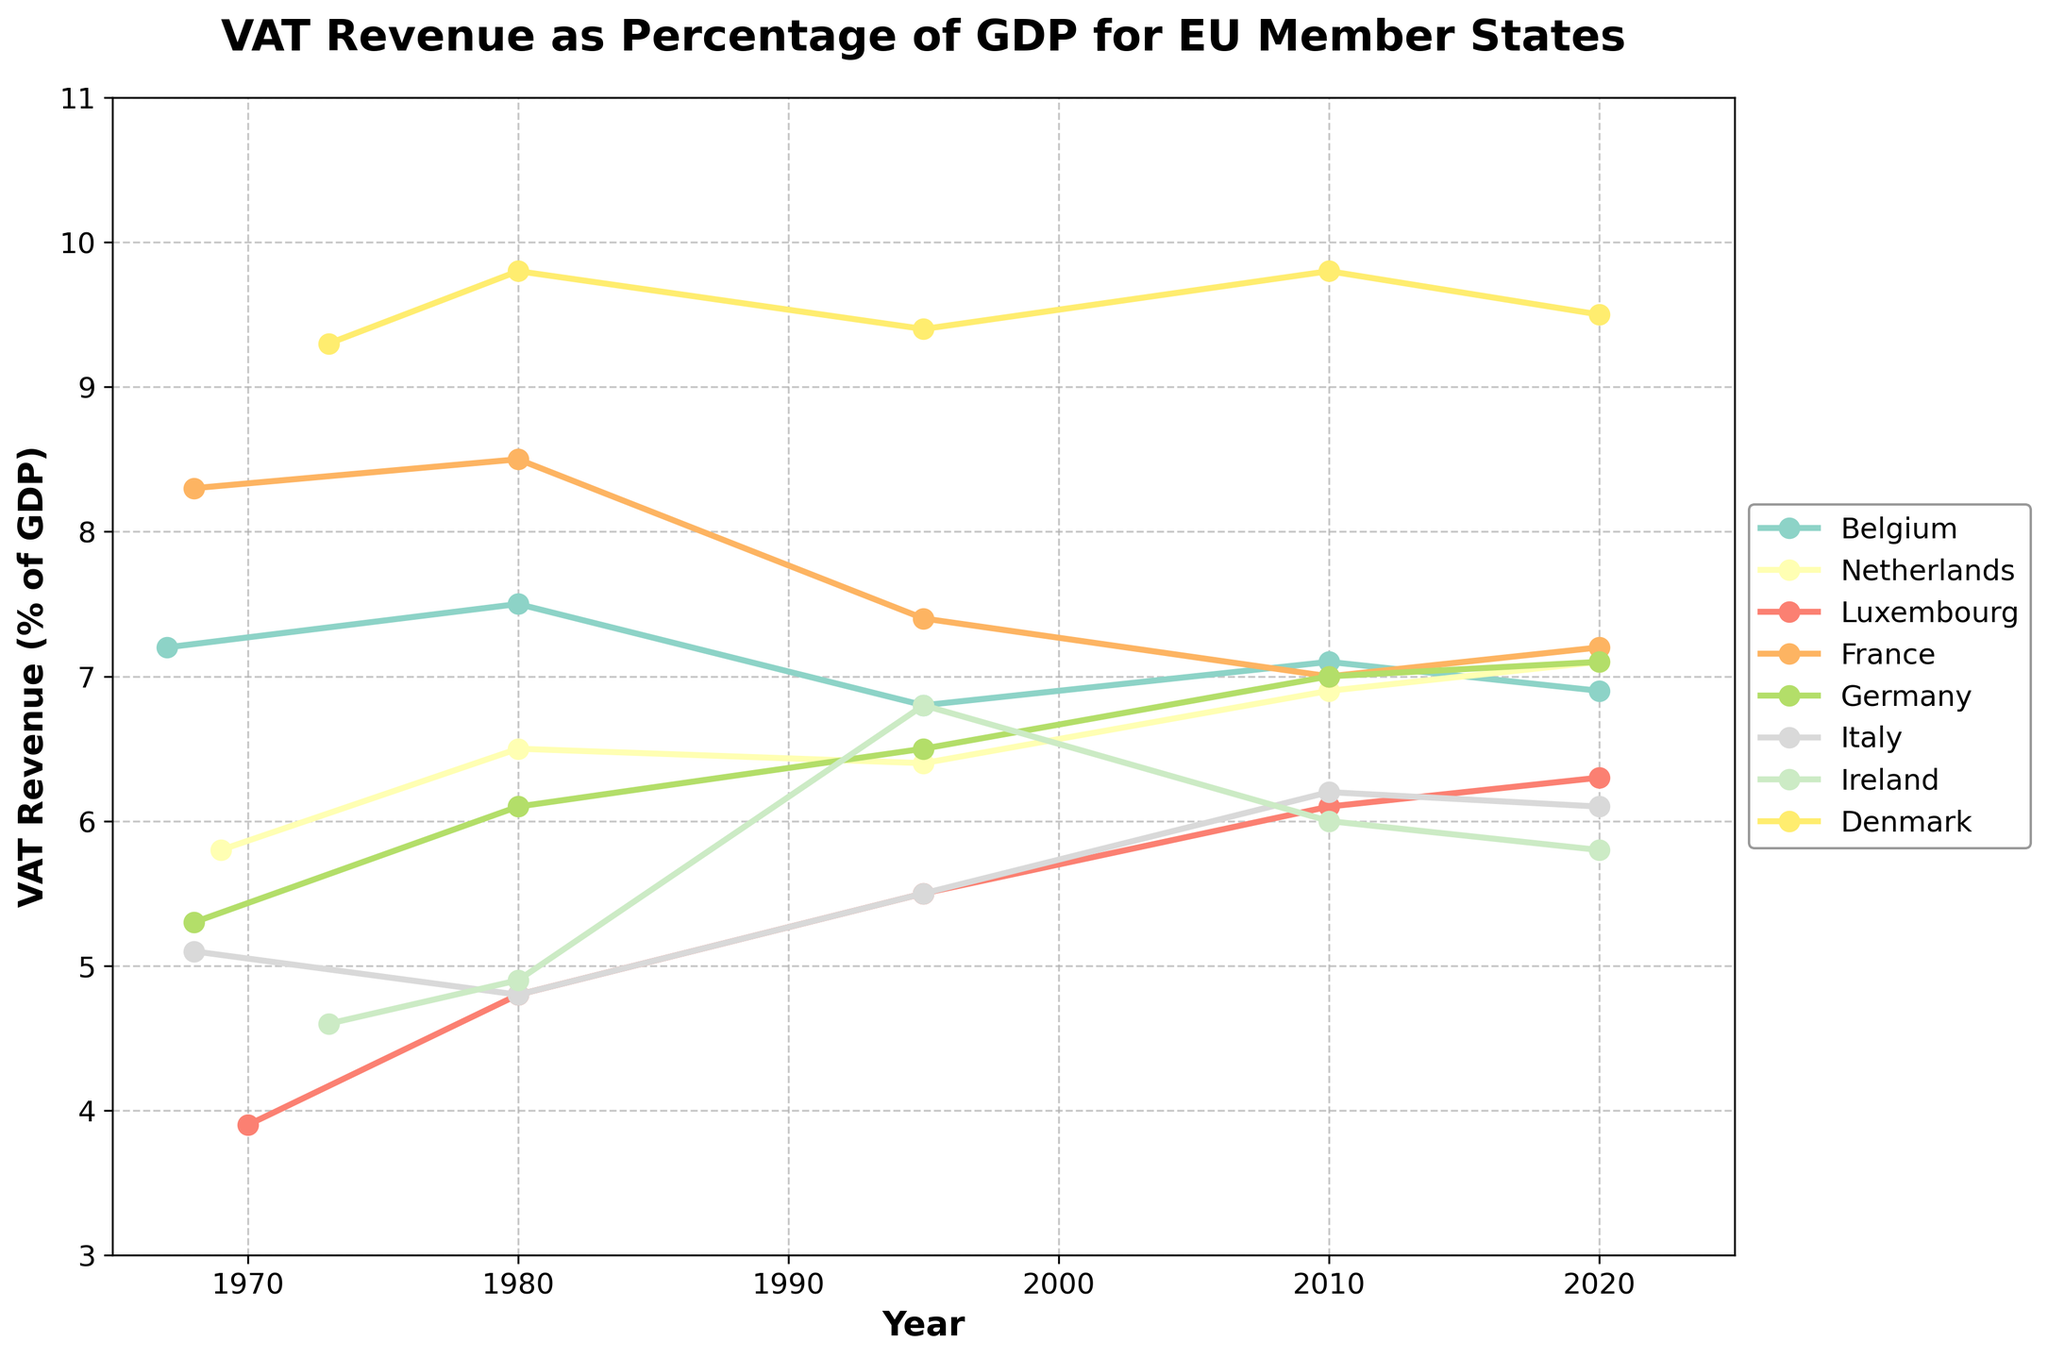What's the trend of VAT revenue as a percentage of GDP for Belgium from 1967 to 2020? The plot shows the VAT revenue for Belgium starts at 7.2% in 1967, increases to 7.5% in 1980, decreases to 6.8% in 1995, rises slightly to 7.1% in 2010, and then decreases to 6.9% by 2020.
Answer: Fluctuating with a slight decrease overall Which country had the highest VAT revenue as a percentage of GDP in 1980? By examining the 1980 line for all countries, Denmark's line is the highest at 9.8%, surpassing other countries.
Answer: Denmark Between Belgium and Netherlands, which country showed a greater increase in VAT revenue as a percentage of GDP from 1995 to 2020? Belgium's VAT revenue increased from 6.8% in 1995 to 6.9% in 2020 (0.1% increase), while Netherlands' increased from 6.4% in 1995 to 7.1% in 2020 (0.7% increase).
Answer: Netherlands Which country showed the most stable VAT revenue as a percentage of GDP over the years? By observing the lines, Denmark's VAT revenue fluctuates the least, maintaining values close to 9.3%-9.8%.
Answer: Denmark Did France's VAT revenue as a percentage of GDP ever drop below 7% after joining the EU? France's line shows its VAT revenue dropped from 8.3% in 1968 to 7.4% in 1995 and further to 7.0% in 2010 but never below 7%.
Answer: No How did Luxembourg's VAT revenue as a percentage of GDP change between 1970 and 1980, and between 1980 and 1995? From 1970 to 1980, Luxembourg's VAT revenue increased from 3.9% to 4.8% (0.9% increase). From 1980 to 1995, it increased from 4.8% to 5.5% (0.7% increase).
Answer: Increased in both periods Which country had the largest percentage drop in VAT revenue from its early years in the dataset to 2020? Calculate the percentage drop for each country: Belgium (7.2% to 6.9%), Netherlands (5.8% to 7.1%), Luxembourg (3.9% to 6.3%), France (8.3% to 7.2%), Germany (5.3% to 7.1%), Italy (5.1% to 6.1%), Ireland (4.6% to 5.8%), and Denmark (9.3% to 9.5%). France had the largest drop from 8.3% to 7.2%.
Answer: France When did Germany and Italy both have nearly similar VAT revenue as a percentage of GDP? The closest years with similar values are 1995 when Germany had 6.5% and Italy had 5.5%. However, in 2020, both Germany and Italy were very close, with Germany at 7.1% and Italy at 6.1%.
Answer: 2020 What can be inferred about the overall trend of VAT revenue as a percentage of GDP across EU member states from the data shown? Observing the trajectories, many countries show a general increasing trend in VAT revenue as a percentage of GDP over the years, with some fluctuations. Denmark and Germany show more stability, while France shows a decreasing trend.
Answer: General increase with some fluctuations 